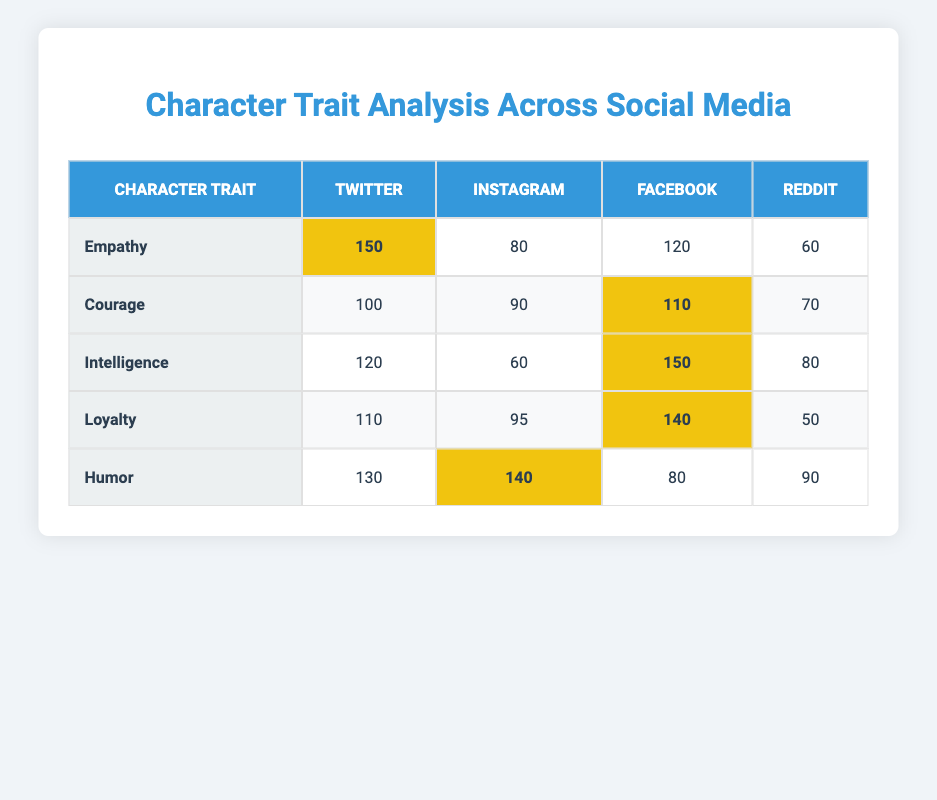What is the frequency of the character trait "Humor" on Instagram? From the table, the frequency for "Humor" on Instagram can be found in the second row under Instagram, which shows a value of 140.
Answer: 140 Which character trait appears most frequently on Twitter? By examining the Twitter column in the table, "Empathy" has the highest frequency at 150.
Answer: Empathy What is the total frequency of "Courage" across all platforms? To find the total frequency of "Courage," sum the values in the Courage row: 100 (Twitter) + 90 (Instagram) + 110 (Facebook) + 70 (Reddit) = 370.
Answer: 370 Is the frequency of "Loyalty" on Reddit greater than on Instagram? Looking at the Loyalty row, the frequency on Reddit is 50, and on Instagram, it is 95. Since 50 is not greater than 95, the answer is no.
Answer: No What is the average frequency of the character trait "Intelligence" across all platforms? To calculate the average, sum the frequencies: 120 (Twitter) + 60 (Instagram) + 150 (Facebook) + 80 (Reddit) = 410. There are 4 platforms, so the average is 410/4 = 102.5.
Answer: 102.5 Which social media platform shows the highest frequency for the trait "Empathy"? Referring to the Empathy row, the highest frequency is recorded on Twitter, which is 150.
Answer: Twitter What is the frequency difference between "Humor" on Twitter and "Courage" on Facebook? The frequency for Humor on Twitter is 130 and for Courage on Facebook is 110. The difference is calculated as 130 - 110 = 20.
Answer: 20 Is there a character trait that has the same frequency on Twitter and Instagram? By comparing the values in the Twitter and Instagram columns row by row, we find "Courage" at 100 (Twitter) and 90 (Instagram), "Empathy" at 150 and 80, "Intelligence" at 120 and 60, "Loyalty" at 110 and 95, and "Humor" at 130 and 140. None are the same, so the answer is no.
Answer: No 